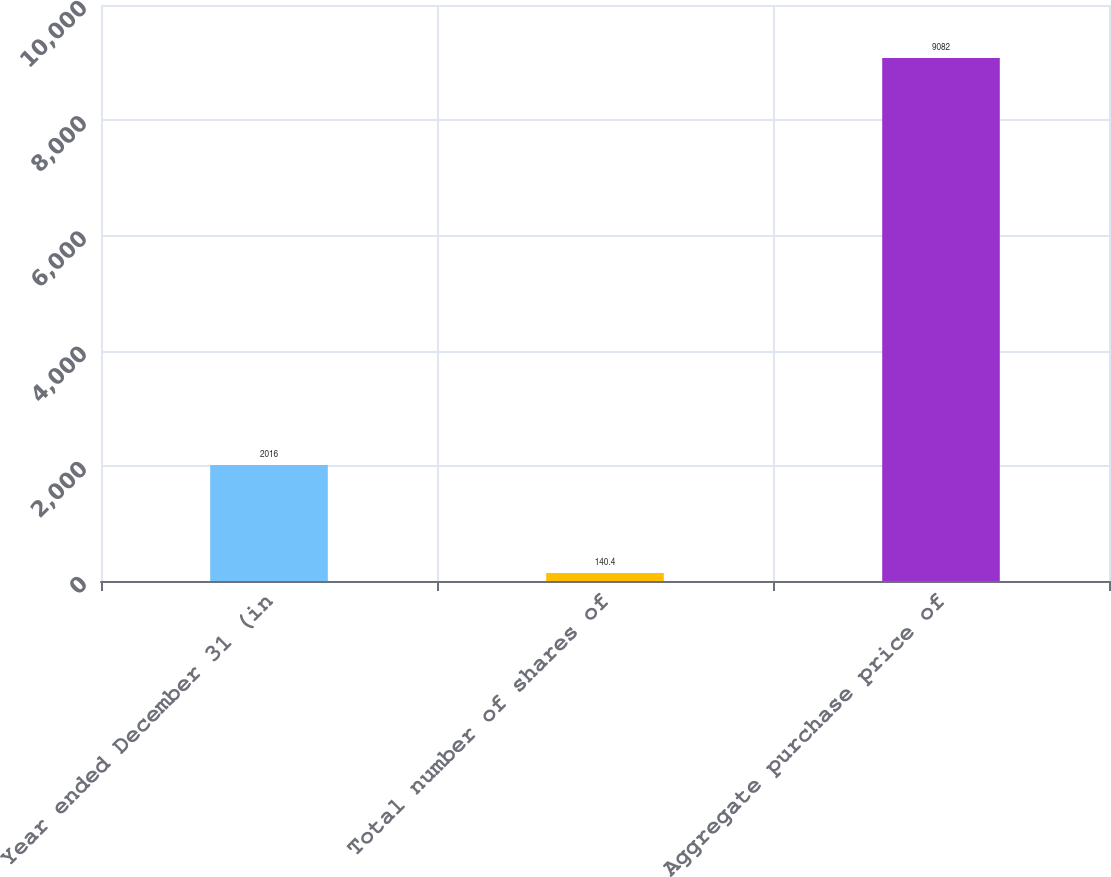Convert chart. <chart><loc_0><loc_0><loc_500><loc_500><bar_chart><fcel>Year ended December 31 (in<fcel>Total number of shares of<fcel>Aggregate purchase price of<nl><fcel>2016<fcel>140.4<fcel>9082<nl></chart> 